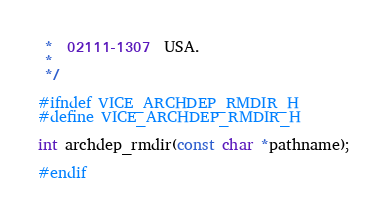Convert code to text. <code><loc_0><loc_0><loc_500><loc_500><_C_> *  02111-1307  USA.
 *
 */

#ifndef VICE_ARCHDEP_RMDIR_H
#define VICE_ARCHDEP_RMDIR_H

int archdep_rmdir(const char *pathname);

#endif
</code> 